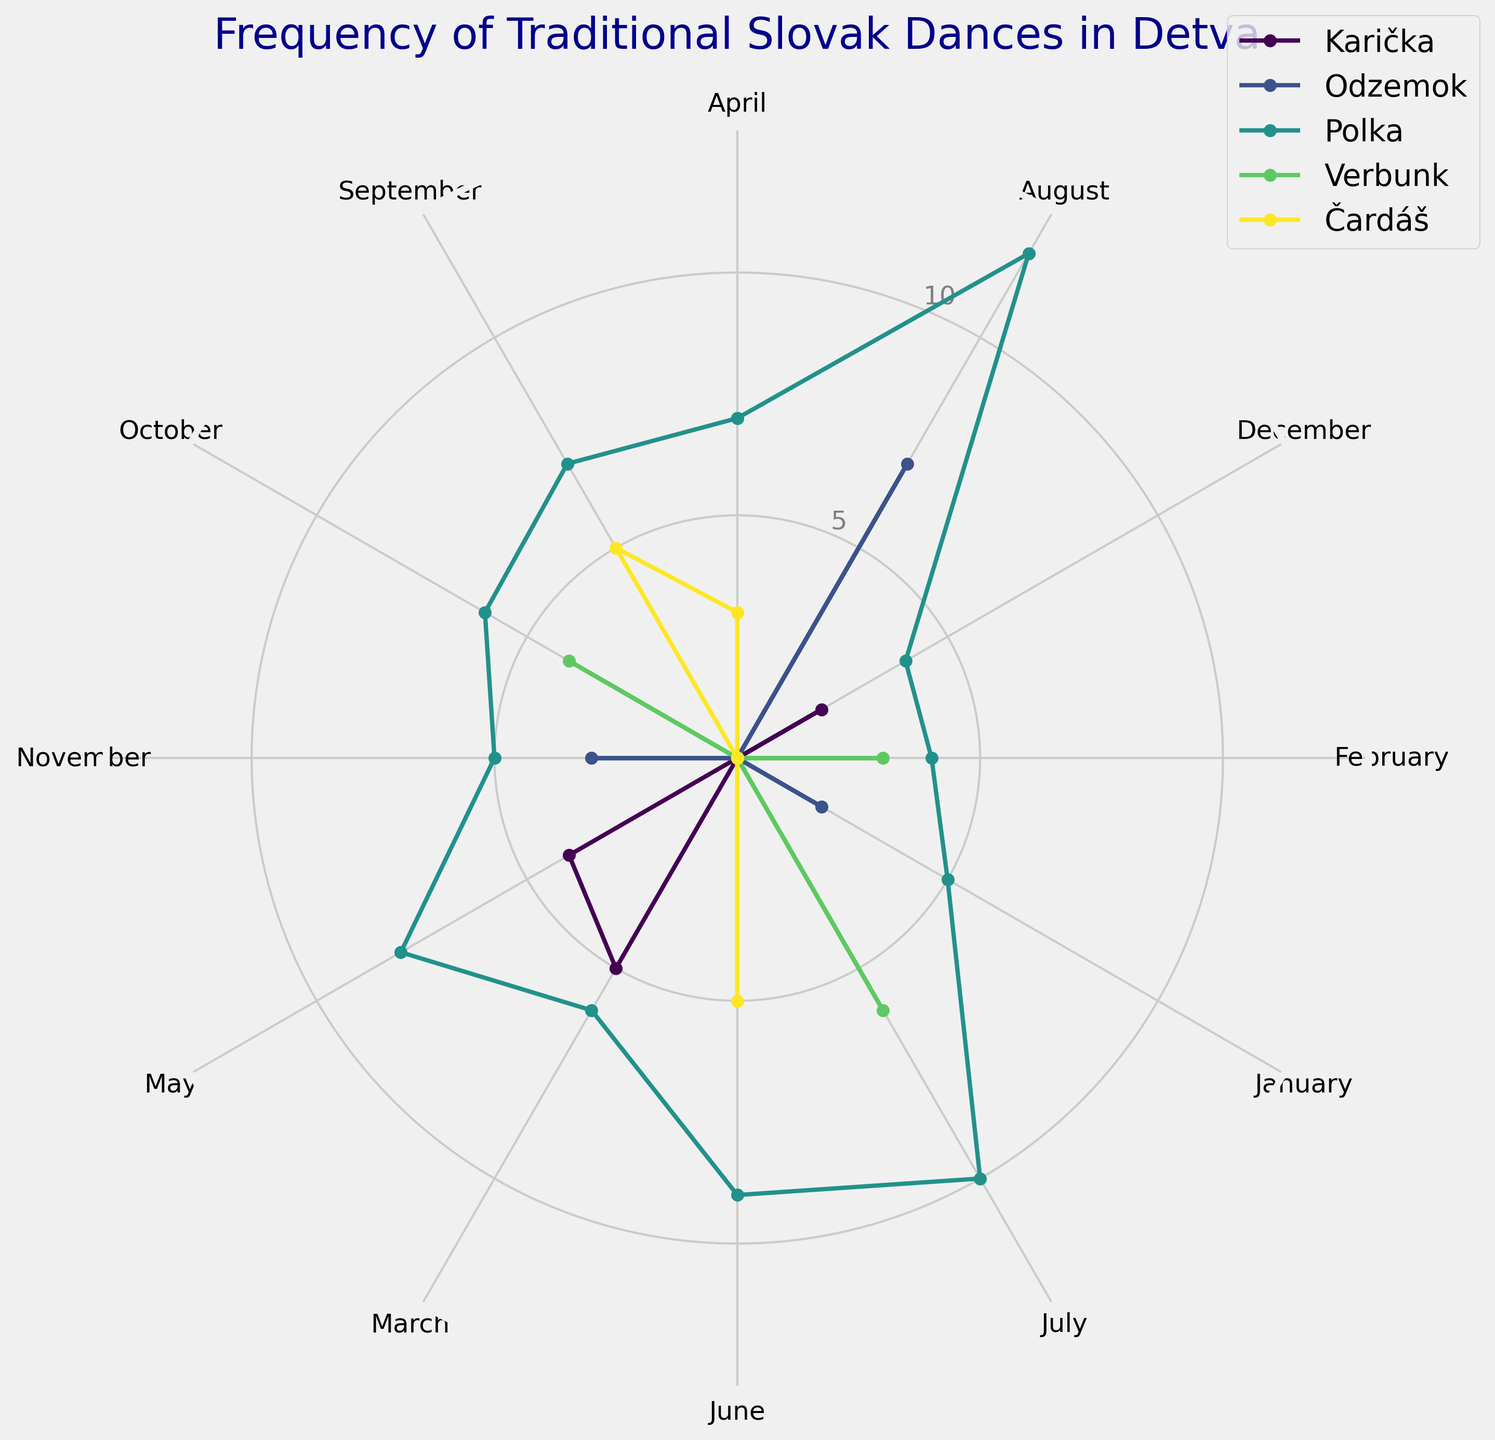Which traditional dance is performed the most frequently in August? The figure shows the frequency of different dances each month. For August, look at the length of the sections for each dance and see which one is the longest.
Answer: Polka How does the frequency of Čardáš in June compare to its frequency in September? Compare the lengths of the segments for Čardáš in June and September. Look at the radial distance for both months.
Answer: They are the same (5 times each) What is the sum of Odzemok and Verbunk frequencies in July? Locate the July segment for both Odzemok and Verbunk and add their frequencies together.
Answer: 6 (Verbunk) + 0 (Odzemok) = 6 Which month has the highest overall frequency of any dance type? Identify the month with the longest radial distance for any dance type.
Answer: August What is the average frequency of Polka across all months? Sum up the frequencies of Polka for all months and divide by the number of months (12).
Answer: (5+4+6+7+8+9+10+12+7+6+5+4) / 12 = 7 In which month is Karička performed, and how often? Check the months that have segments labeled Karička and note their frequencies.
Answer: March (5 times), May (4 times), December (2 times) How does the frequency of dances change from January to December for Odzemok? Compare the length of the segments for Odzemok in January and December; check if there is an increase or decrease.
Answer: January (2 times) to December (0 times), decreases Which dance type has the least variation in its performance frequency across all months? Check the dance type with the most consistent (less variable) segment lengths across all months.
Answer: Verbunk If the frequencies of Maliarada and Varživo were added to the figure, in which month might you expect the highest overall frequency? Assuming Maliarada and Varživo follow similar patterns, estimate the month with the highest frequency by looking at the highest existing frequencies.
Answer: August 